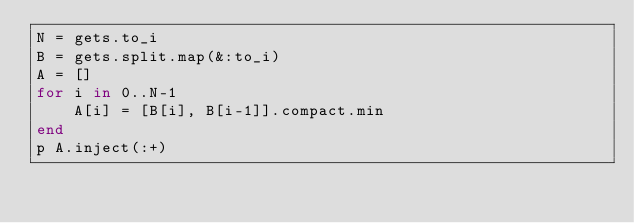<code> <loc_0><loc_0><loc_500><loc_500><_Ruby_>N = gets.to_i
B = gets.split.map(&:to_i)
A = []
for i in 0..N-1
    A[i] = [B[i], B[i-1]].compact.min
end
p A.inject(:+)</code> 